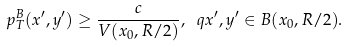<formula> <loc_0><loc_0><loc_500><loc_500>p ^ { B } _ { T } ( x ^ { \prime } , y ^ { \prime } ) \geq \frac { c } { V ( x _ { 0 } , R / 2 ) } , \ q x ^ { \prime } , y ^ { \prime } \in B ( x _ { 0 } , R / 2 ) .</formula> 